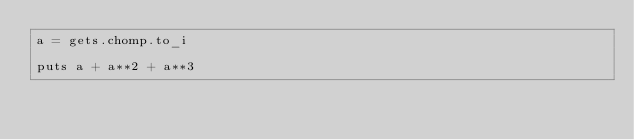<code> <loc_0><loc_0><loc_500><loc_500><_Ruby_>a = gets.chomp.to_i

puts a + a**2 + a**3</code> 